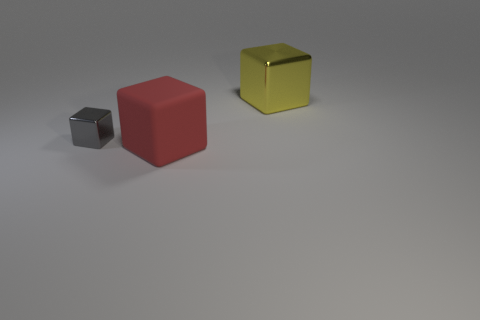Subtract all gray blocks. How many blocks are left? 2 Subtract all big cubes. How many cubes are left? 1 Add 2 large blue rubber things. How many objects exist? 5 Subtract all yellow cylinders. How many yellow blocks are left? 1 Add 2 large red blocks. How many large red blocks exist? 3 Subtract 0 yellow balls. How many objects are left? 3 Subtract all purple cubes. Subtract all brown spheres. How many cubes are left? 3 Subtract all tiny cubes. Subtract all small green objects. How many objects are left? 2 Add 1 red things. How many red things are left? 2 